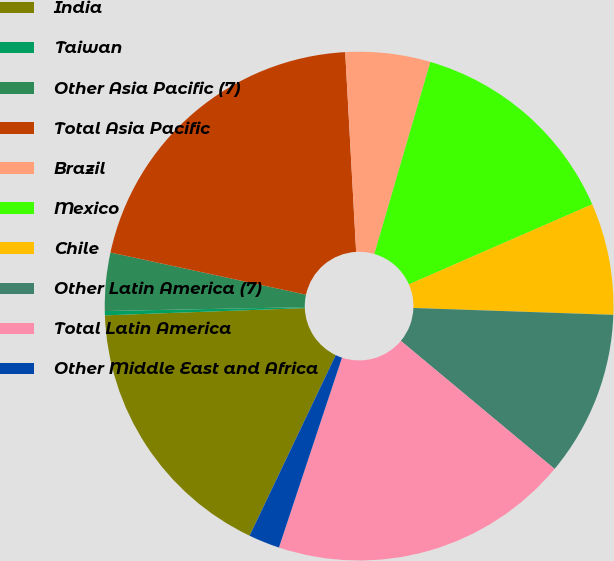Convert chart to OTSL. <chart><loc_0><loc_0><loc_500><loc_500><pie_chart><fcel>India<fcel>Taiwan<fcel>Other Asia Pacific (7)<fcel>Total Asia Pacific<fcel>Brazil<fcel>Mexico<fcel>Chile<fcel>Other Latin America (7)<fcel>Total Latin America<fcel>Other Middle East and Africa<nl><fcel>17.34%<fcel>0.27%<fcel>3.69%<fcel>20.75%<fcel>5.39%<fcel>13.93%<fcel>7.1%<fcel>10.51%<fcel>19.05%<fcel>1.98%<nl></chart> 